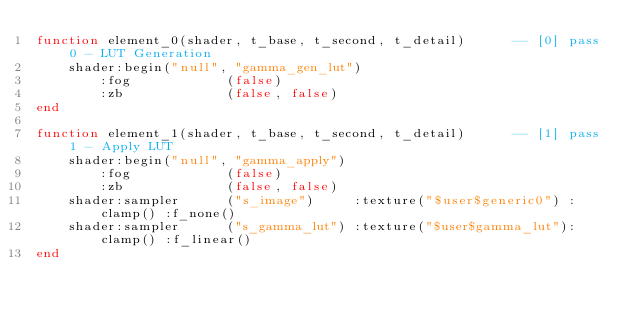Convert code to text. <code><loc_0><loc_0><loc_500><loc_500><_Lua_>function element_0(shader, t_base, t_second, t_detail)		-- [0] pass 0 - LUT Generation
	shader:begin("null", "gamma_gen_lut")
		:fog			(false)
		:zb				(false, false)
end

function element_1(shader, t_base, t_second, t_detail)		-- [1] pass 1 - Apply LUT
	shader:begin("null", "gamma_apply")
		:fog			(false)
		:zb				(false, false)
	shader:sampler		("s_image")		:texture("$user$generic0") :clamp()	:f_none()
	shader:sampler		("s_gamma_lut")	:texture("$user$gamma_lut"):clamp() :f_linear()
end</code> 